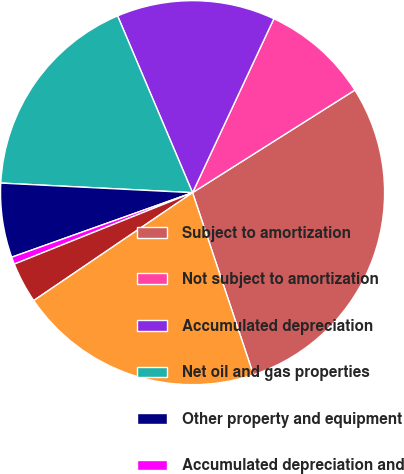Convert chart to OTSL. <chart><loc_0><loc_0><loc_500><loc_500><pie_chart><fcel>Subject to amortization<fcel>Not subject to amortization<fcel>Accumulated depreciation<fcel>Net oil and gas properties<fcel>Other property and equipment<fcel>Accumulated depreciation and<fcel>Net other property and<fcel>Property and equipment net of<nl><fcel>28.83%<fcel>9.07%<fcel>13.34%<fcel>17.82%<fcel>6.25%<fcel>0.61%<fcel>3.43%<fcel>20.64%<nl></chart> 